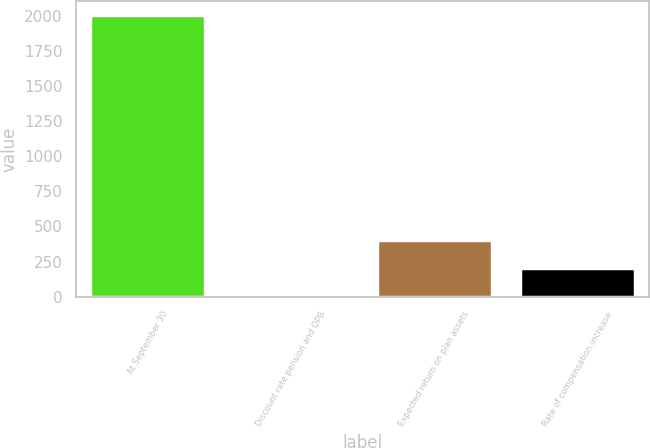Convert chart to OTSL. <chart><loc_0><loc_0><loc_500><loc_500><bar_chart><fcel>At September 30<fcel>Discount rate pension and OPB<fcel>Expected return on plan assets<fcel>Rate of compensation increase<nl><fcel>2005<fcel>5.5<fcel>405.4<fcel>205.45<nl></chart> 